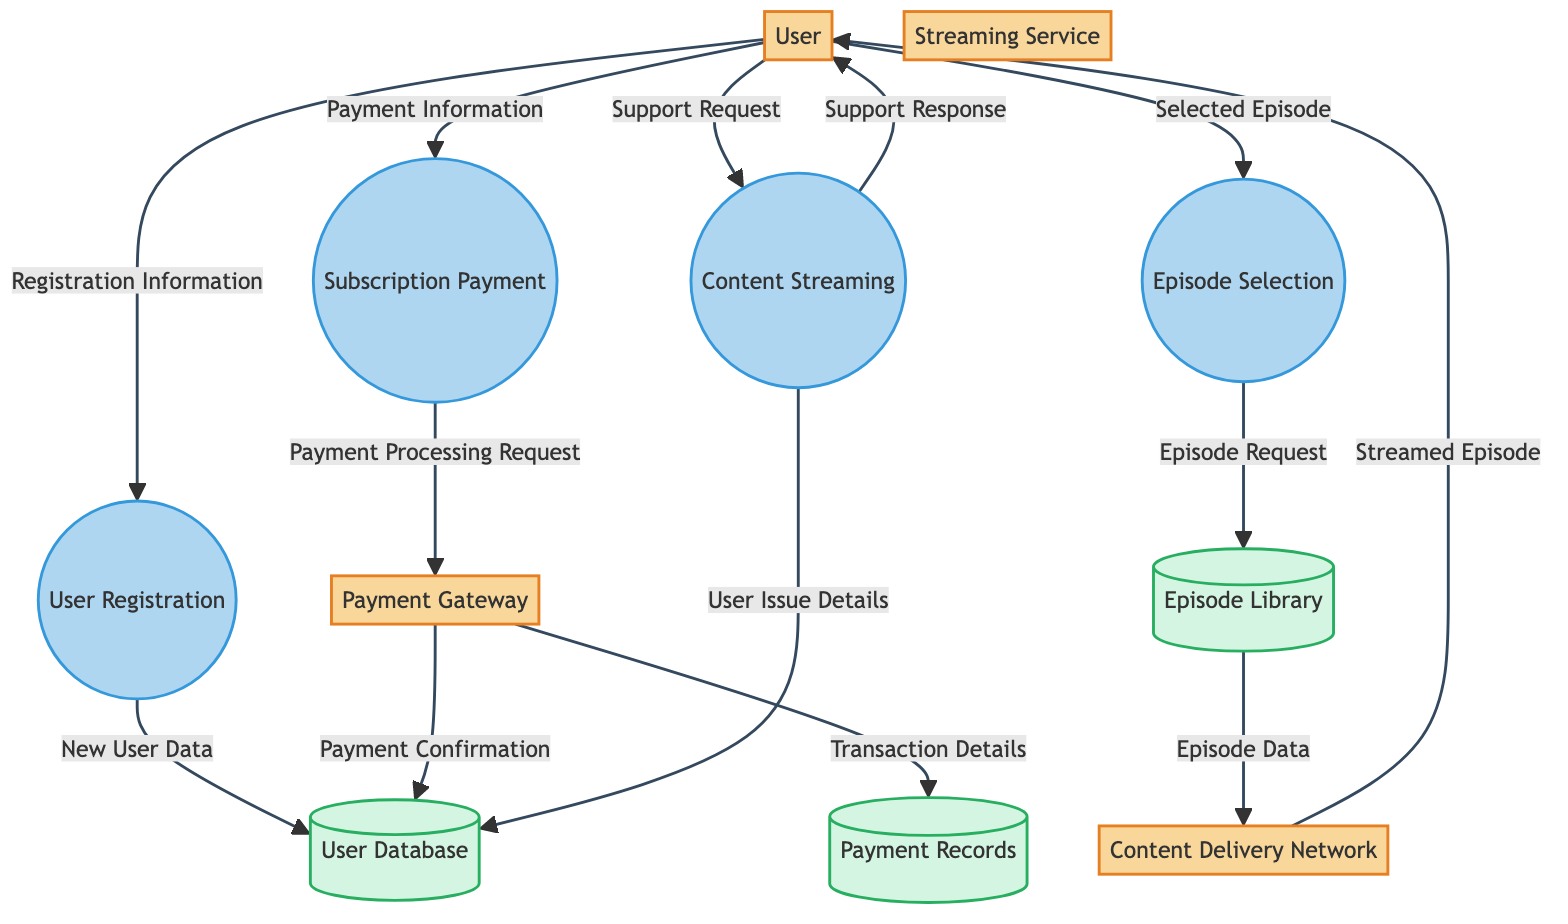What is the first process a user goes through? The first process indicated in the diagram for a user is "User Registration". This is shown by the arrow starting from User and pointing to the User Registration process, indicating that the user initiates the registration.
Answer: User Registration How many data stores are in the diagram? The diagram shows three data stores: User Database, Payment Records, and Episode Library. These are identified as separate entities that store different types of information.
Answer: Three What data flows from the Subscription Payment process to the Payment Gateway? The arrow going from the Subscription Payment process to the Payment Gateway indicates a flow labeled "Payment Processing Request". This represents the request that the system sends to process the user's subscription payment.
Answer: Payment Processing Request Which entity sends a Support Request? The User entity sends a Support Request to Customer Support, as indicated by the arrow showing the flow from User directed towards the Customer Support process.
Answer: User What does the Content Delivery Network (CDN) send to the User? The Content Delivery Network sends "Streamed Episode" to the User. This is indicated by the flow from CDN to User, showing what content is delivered after processing.
Answer: Streamed Episode Which process receives Selected Episode data from the User? The Episode Selection process receives "Selected Episode" data from the User. The flow from User to Episode Selection illustrates this interaction directly.
Answer: Episode Selection How many processes are depicted in the diagram? The diagram indicates four processes: User Registration, Subscription Payment, Episode Selection, and Content Streaming. These processes represent the actions users can take on the streaming service.
Answer: Four What is stored in the Payment Records data store? The Payment Records data store contains "Transaction Details". This is indicated by the flow from Payment Gateway to Payment Records, which outlines what specific information is stored.
Answer: Transaction Details What entity interacts directly with Customer Support? The User interacts directly with Customer Support, as shown by the flow from User to Customer Support. This indicates that users can send requests for help.
Answer: User 